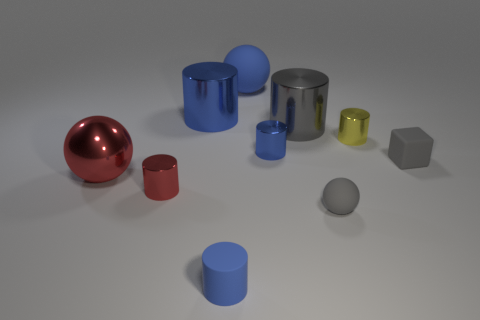There is a big cylinder that is the same color as the large rubber object; what is it made of?
Keep it short and to the point. Metal. How many other things are there of the same material as the gray sphere?
Give a very brief answer. 3. The thing that is behind the small red metallic cylinder and on the left side of the big blue shiny object has what shape?
Ensure brevity in your answer.  Sphere. Is the size of the blue cylinder in front of the matte cube the same as the blue matte object that is behind the gray cube?
Keep it short and to the point. No. The gray object that is the same material as the small yellow cylinder is what shape?
Offer a very short reply. Cylinder. Are there any other things that are the same shape as the gray metal thing?
Offer a very short reply. Yes. What color is the matte sphere that is in front of the thing that is behind the large blue metal cylinder behind the yellow thing?
Provide a succinct answer. Gray. Are there fewer red metallic cylinders that are right of the cube than small gray rubber objects that are behind the big gray metallic cylinder?
Keep it short and to the point. No. Is the tiny red shiny thing the same shape as the big gray thing?
Provide a succinct answer. Yes. How many shiny objects have the same size as the matte cylinder?
Make the answer very short. 3. 